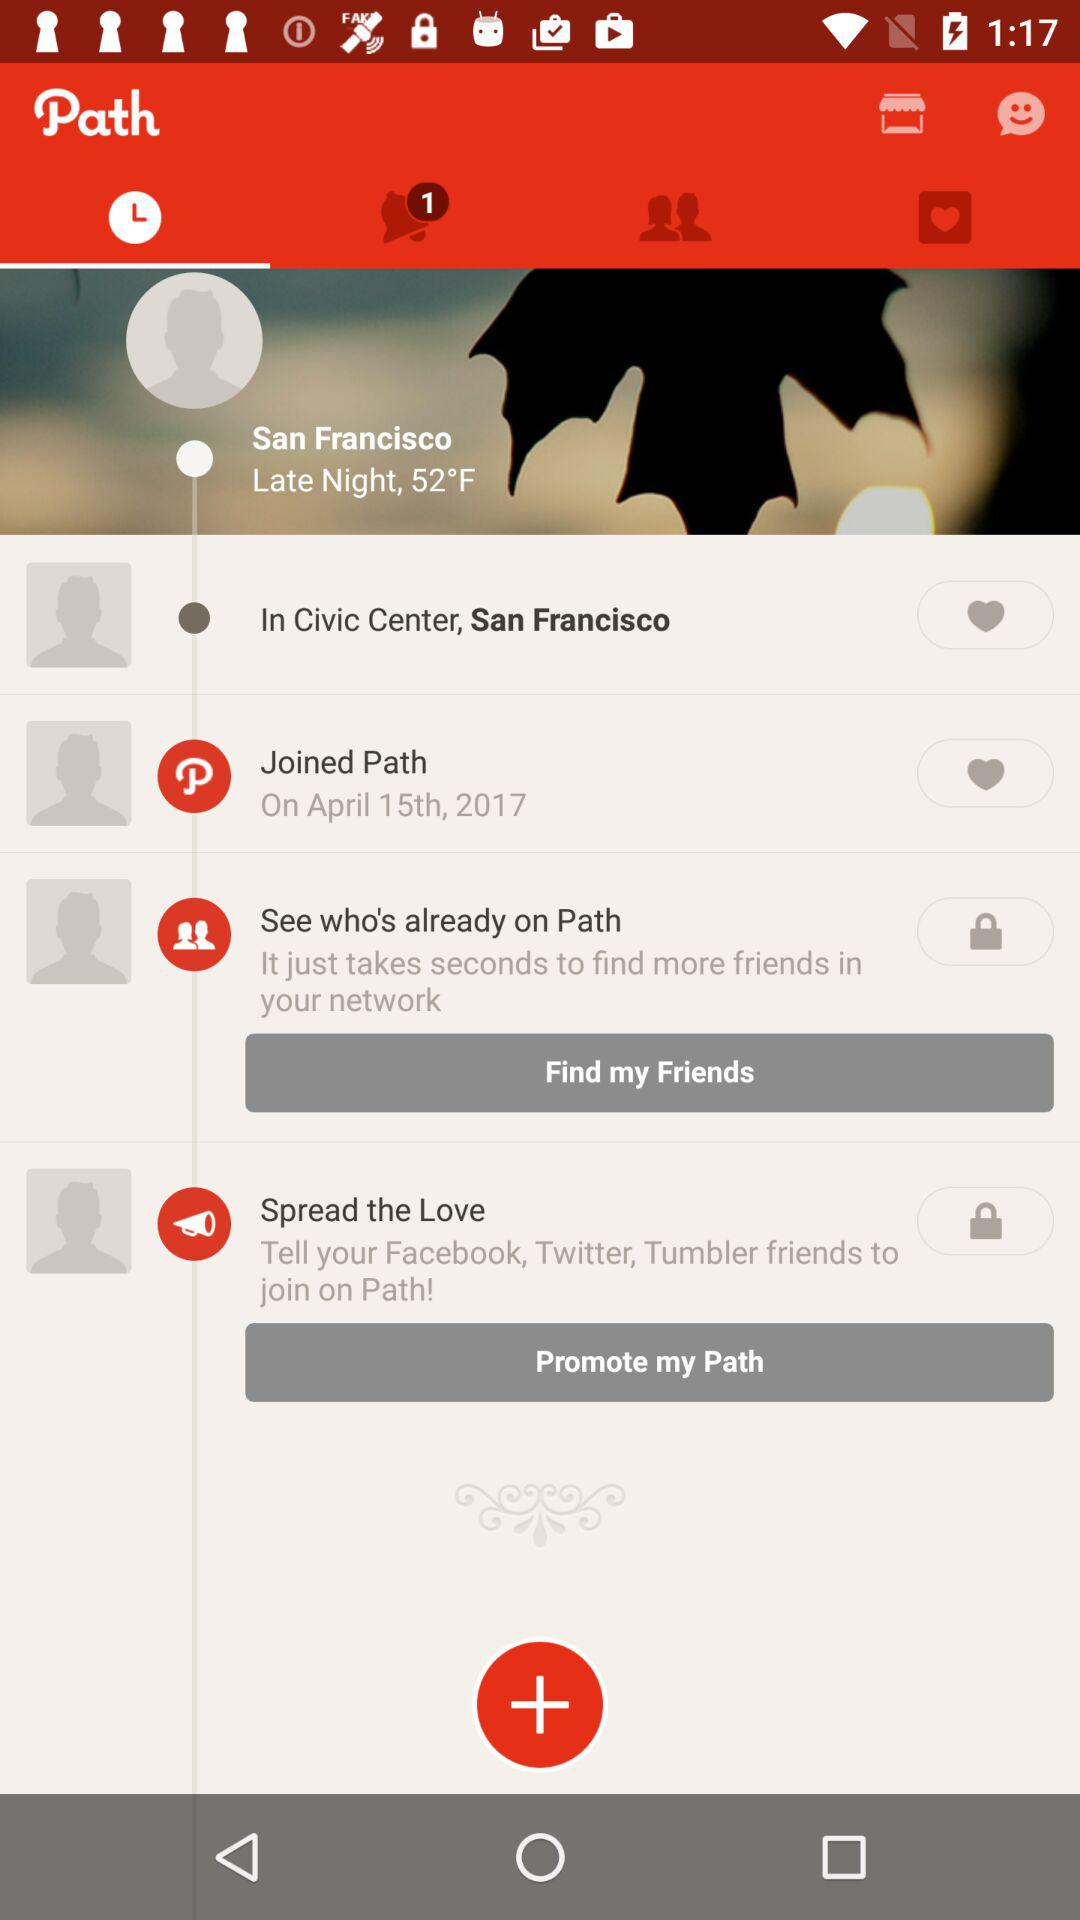What is the given location? The given location is San Francisco. 